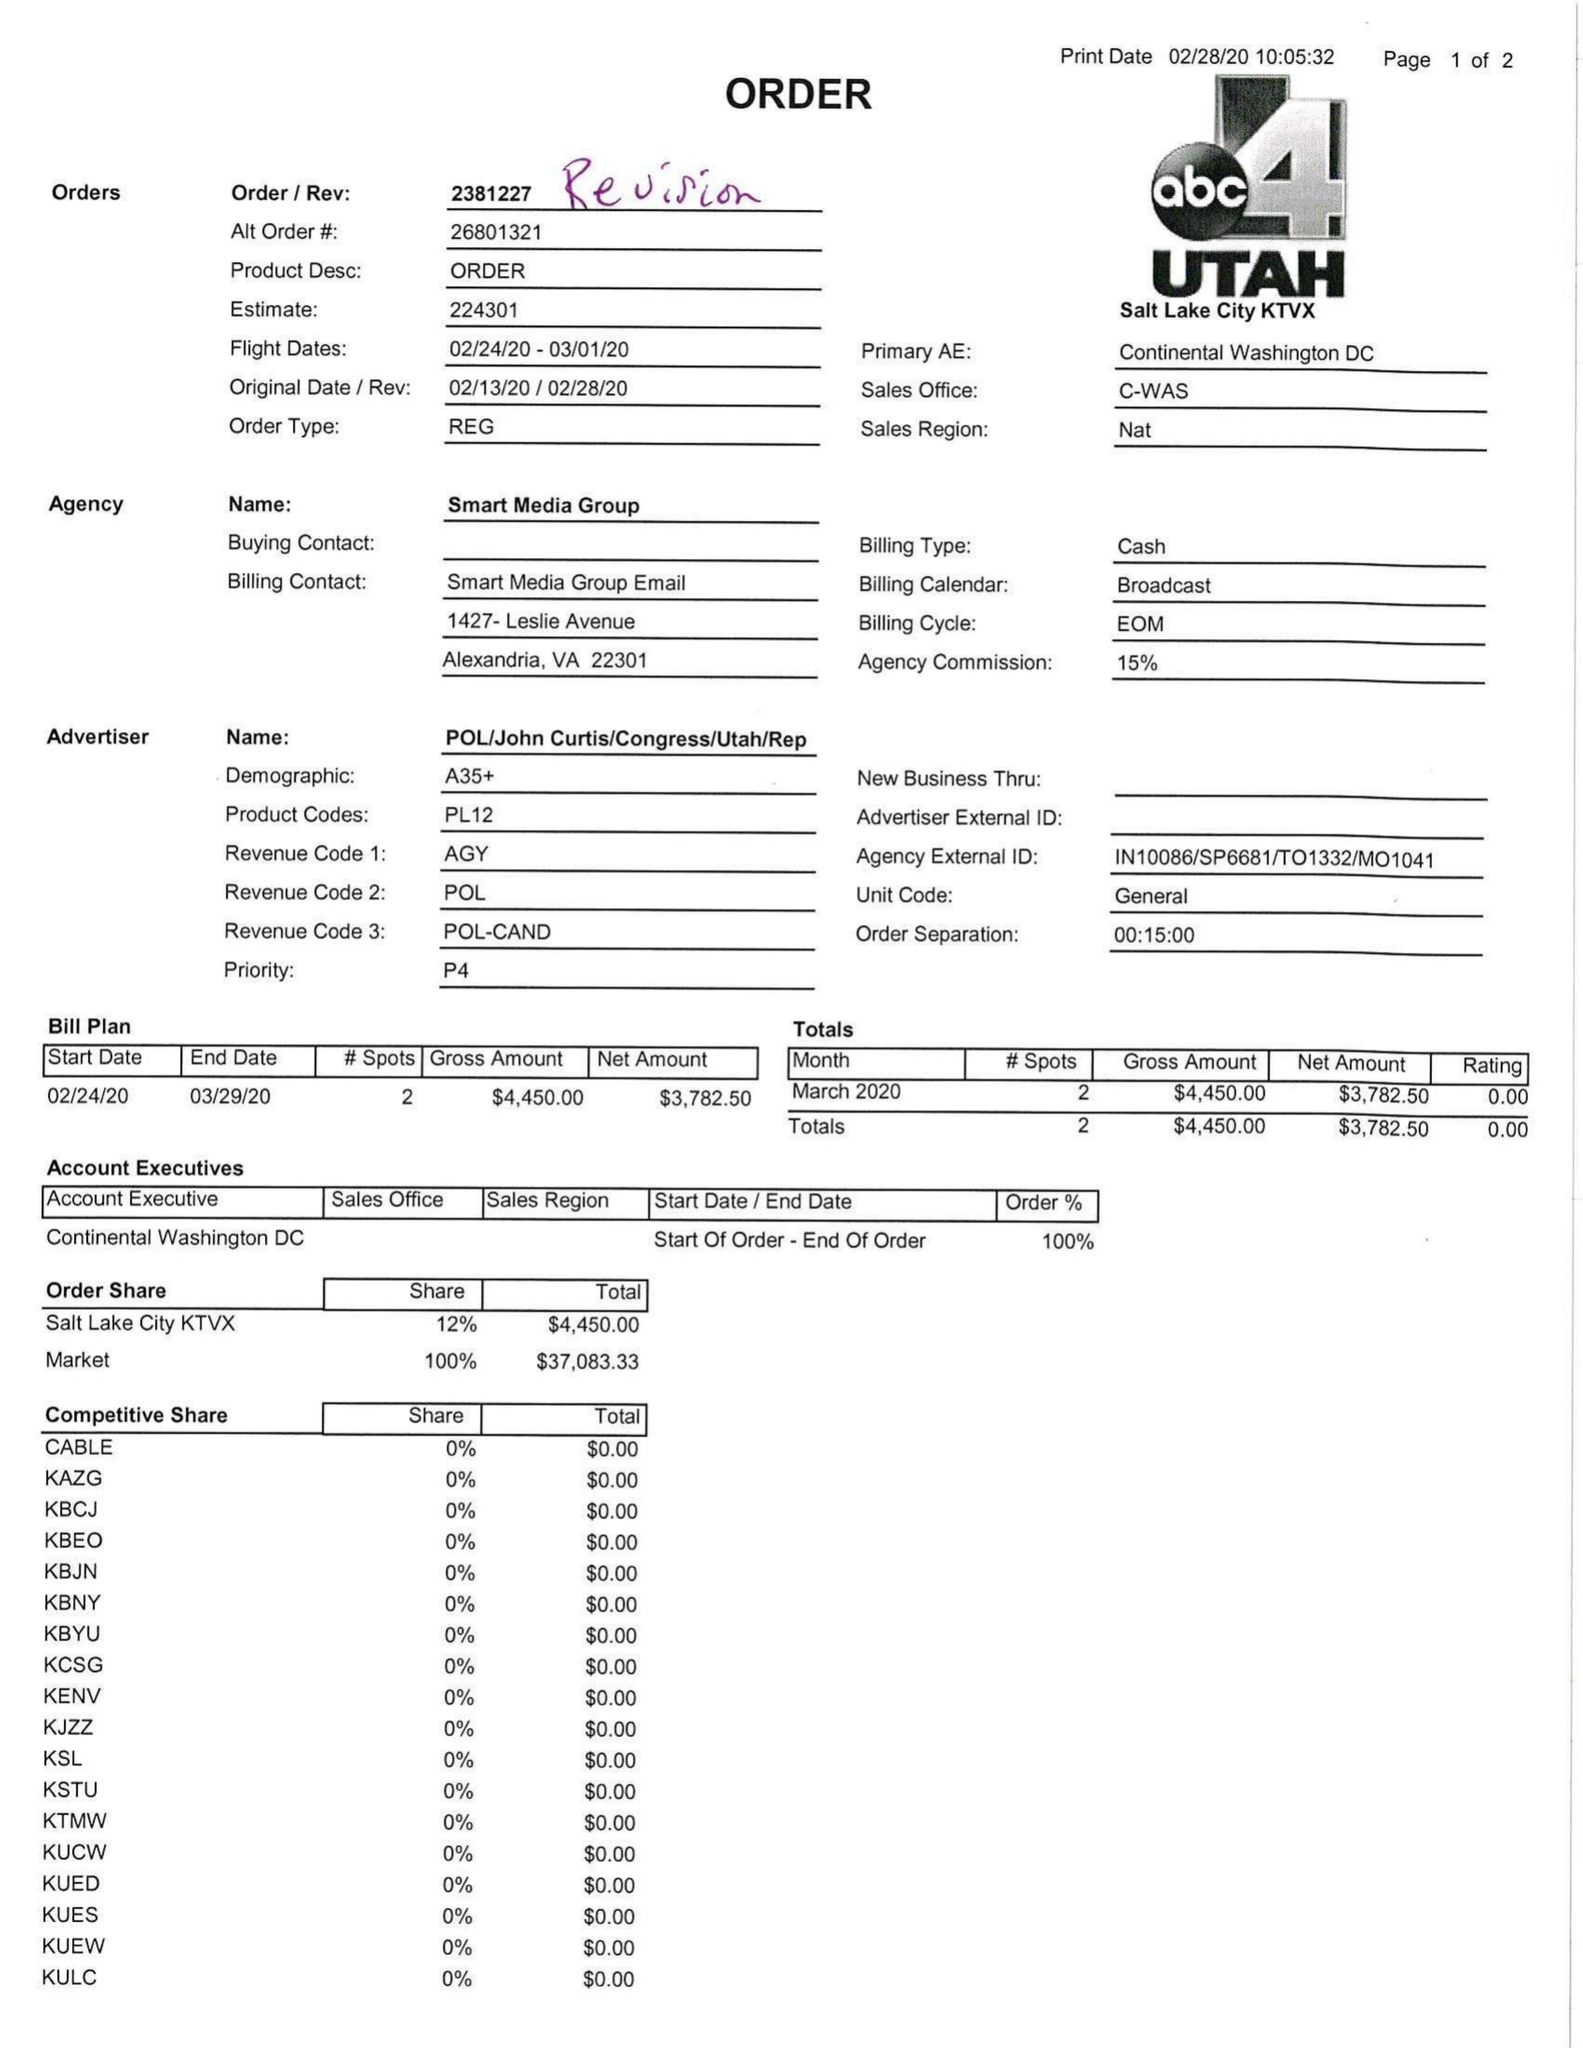What is the value for the gross_amount?
Answer the question using a single word or phrase. 4450.00 